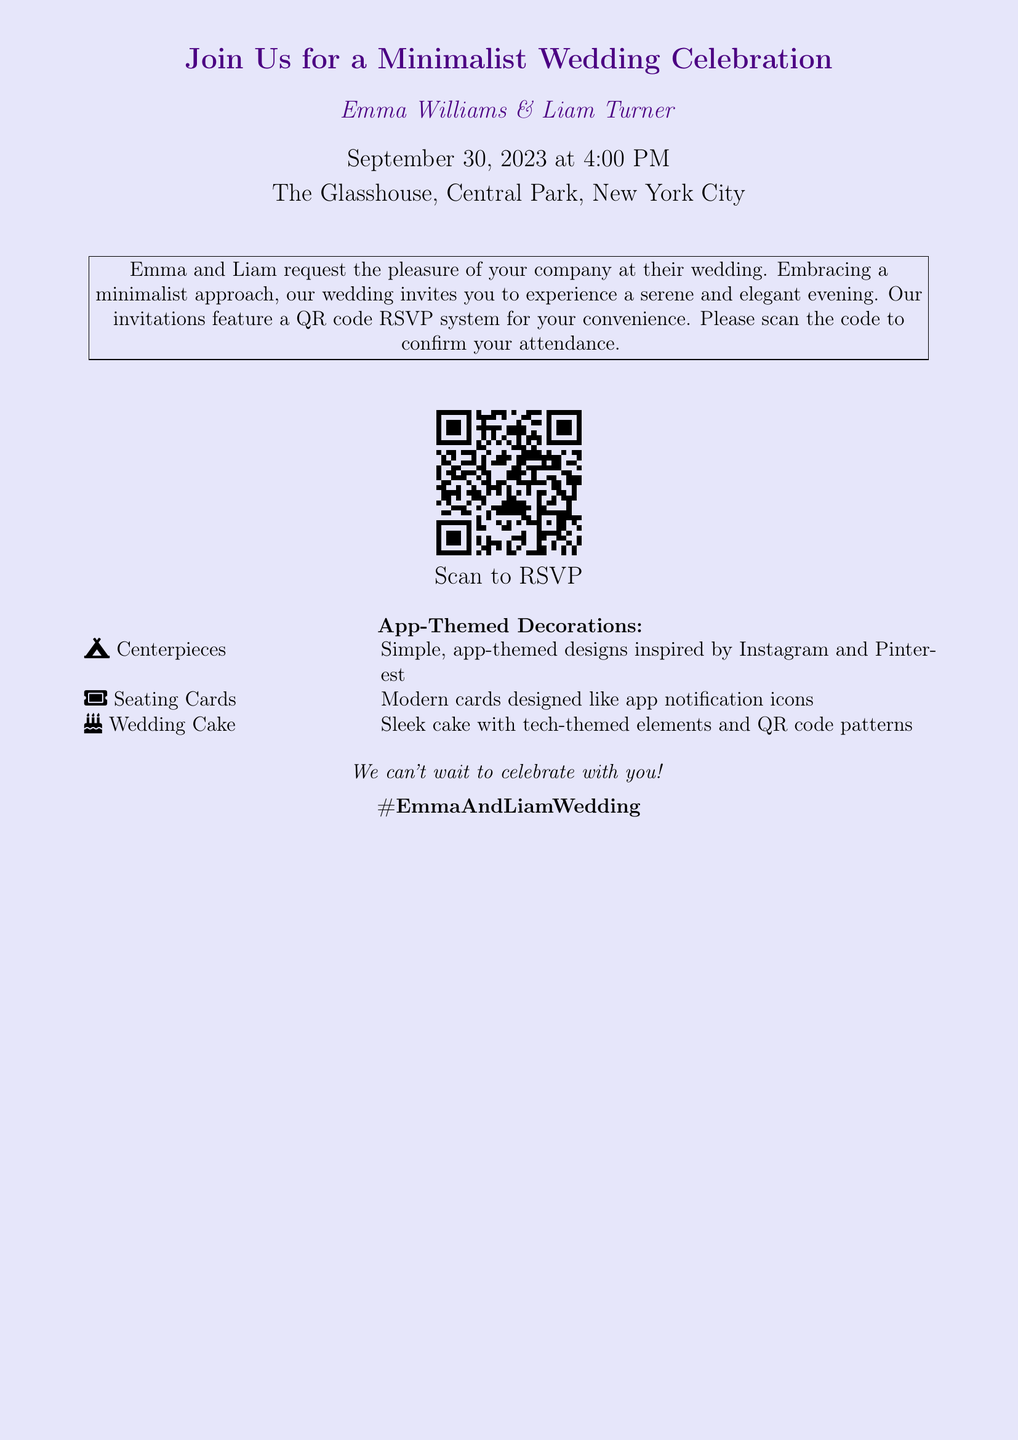What is the date of the wedding? The date of the wedding is stated clearly in the invitation as September 30, 2023.
Answer: September 30, 2023 Who are the couple getting married? The invitation mentions the names of the couple as Emma Williams and Liam Turner.
Answer: Emma Williams & Liam Turner What time does the wedding start? The invitation specifies the time of the wedding, which is at 4:00 PM.
Answer: 4:00 PM Where is the wedding venue? The address of the wedding venue is provided in the invitation as The Glasshouse, Central Park, New York City.
Answer: The Glasshouse, Central Park, New York City What feature is included to RSVP? The invitation notes that there is a QR code for guests to scan and confirm their attendance.
Answer: QR code RSVP system What is the theme of the decorations? The document describes the decorations as app-themed, inspired by platforms like Instagram and Pinterest.
Answer: App-Themed Decorations What is included in the centerpieces? The centerpieces are mentioned to have simple, app-themed designs.
Answer: Simple, app-themed designs How is the wedding cake described? The invitation states that the wedding cake features tech-themed elements and QR code patterns.
Answer: Tech-themed elements and QR code patterns What social media hashtag is associated with the wedding? The invitation includes the hashtag for the event, which is #EmmaAndLiamWedding.
Answer: #EmmaAndLiamWedding 